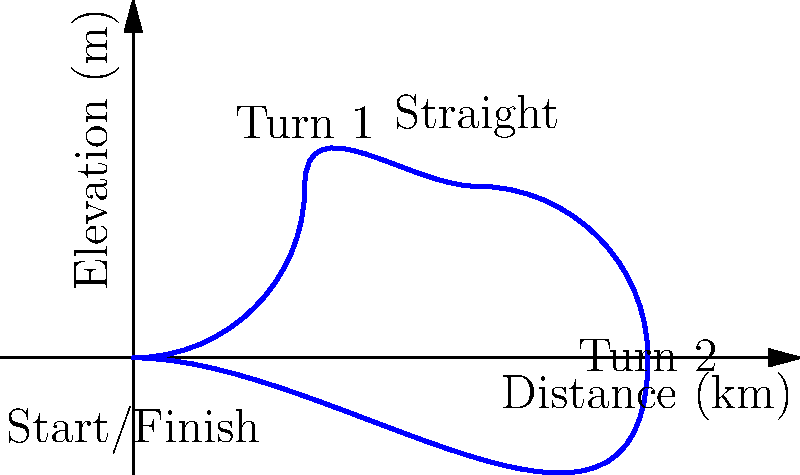Based on the track layout diagram, which machine learning model would be most suitable for predicting lap times, and why? To predict lap times based on the given track layout, we need to consider the following steps:

1. Analyze the track features:
   - The track has two main turns and a straight section
   - There are elevation changes throughout the circuit

2. Identify relevant input variables:
   - Track length
   - Number of turns
   - Turn angles
   - Straight section length
   - Elevation changes

3. Consider the complexity of the problem:
   - Non-linear relationships between features and lap times
   - Potential interactions between variables

4. Evaluate machine learning models:
   - Linear Regression: Too simple for this complex problem
   - Decision Trees: Can capture non-linear relationships but may overfit
   - Random Forest: Improves upon decision trees, reduces overfitting
   - Support Vector Machines: Can handle non-linear relationships but may struggle with interpretability
   - Neural Networks: Can capture complex patterns but require large datasets

5. Select the most suitable model:
   Random Forest would be the most appropriate choice because:
   - It can capture non-linear relationships between track features and lap times
   - It handles interactions between variables well
   - It's less prone to overfitting compared to a single decision tree
   - It provides feature importance, which is useful for understanding key factors affecting lap times
   - It doesn't require extensive data preprocessing or feature scaling

6. Additional considerations:
   - Collect sufficient historical data on lap times and track conditions
   - Incorporate weather data and tire compound information for more accurate predictions
   - Regularly update the model with new data to improve its performance over time
Answer: Random Forest 